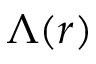Convert formula to latex. <formula><loc_0><loc_0><loc_500><loc_500>\Lambda ( r )</formula> 